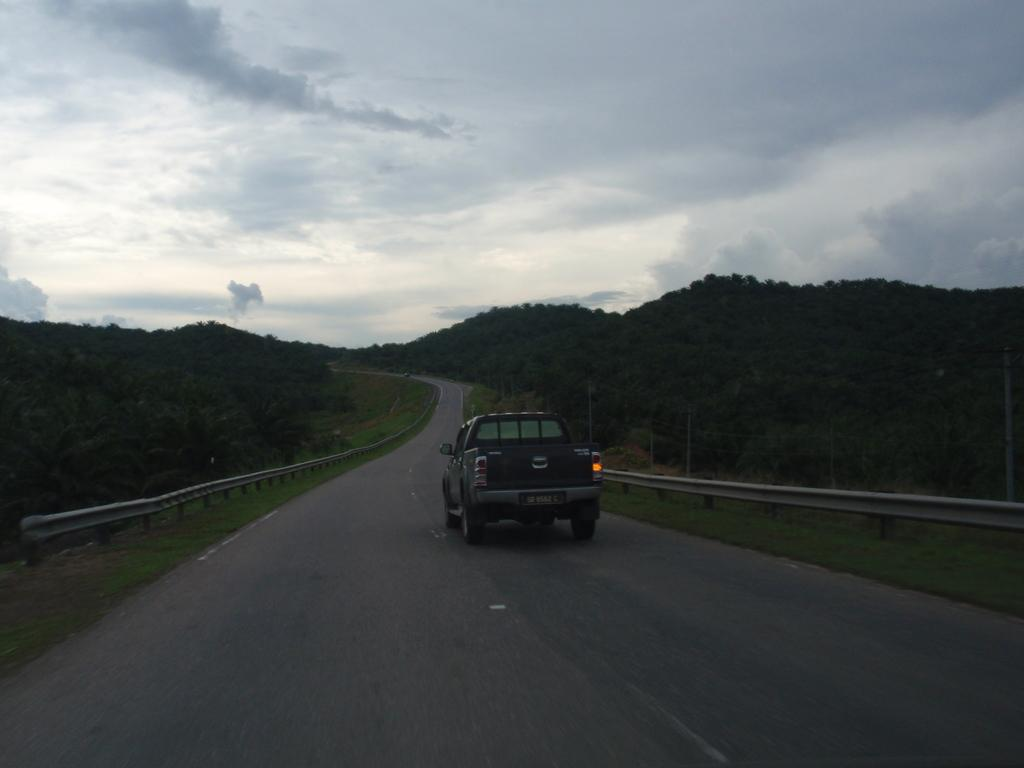What is on the road in the image? There is a vehicle on the road in the image. What type of natural elements can be seen in the image? Trees are visible in the image. How would you describe the sky in the image? The sky is blue and cloudy in the image. Where is the brother sitting in the carriage in the image? There is no brother or carriage present in the image. 